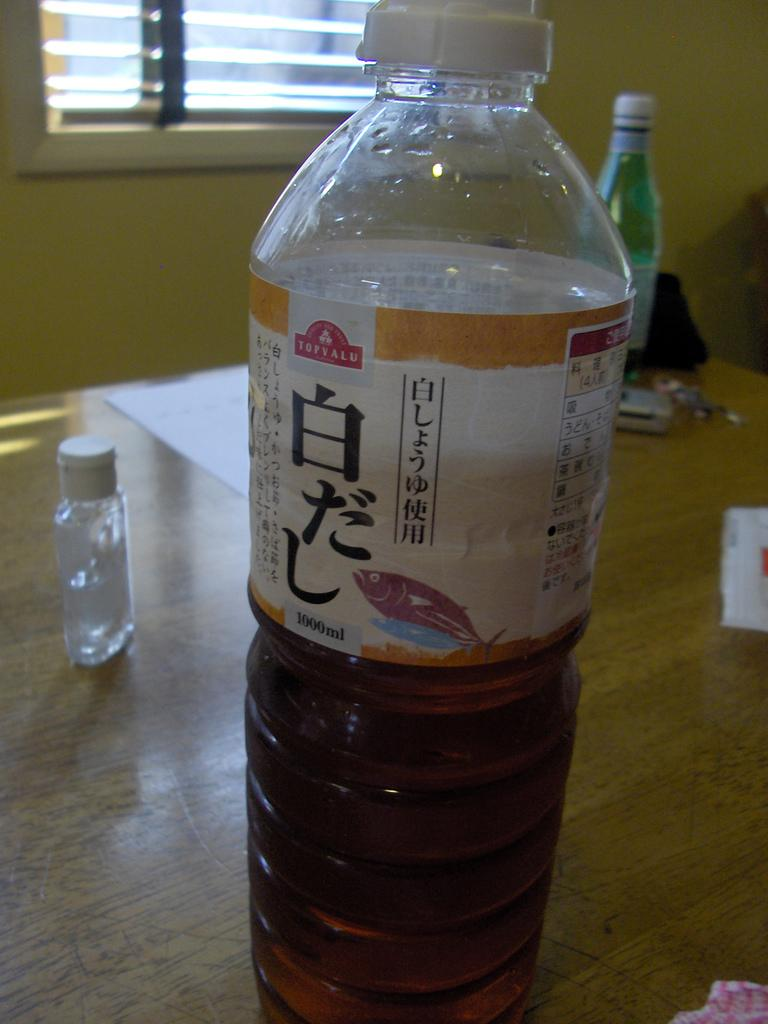<image>
Render a clear and concise summary of the photo. A clear bottle half filled with brown liquid with a Topvalu logo on it sits on a wooden table. 